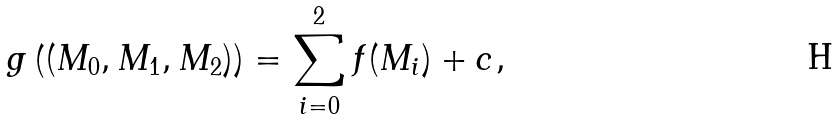<formula> <loc_0><loc_0><loc_500><loc_500>g \left ( ( M _ { 0 } , M _ { 1 } , M _ { 2 } ) \right ) = \sum _ { i = 0 } ^ { 2 } f ( M _ { i } ) + c ,</formula> 